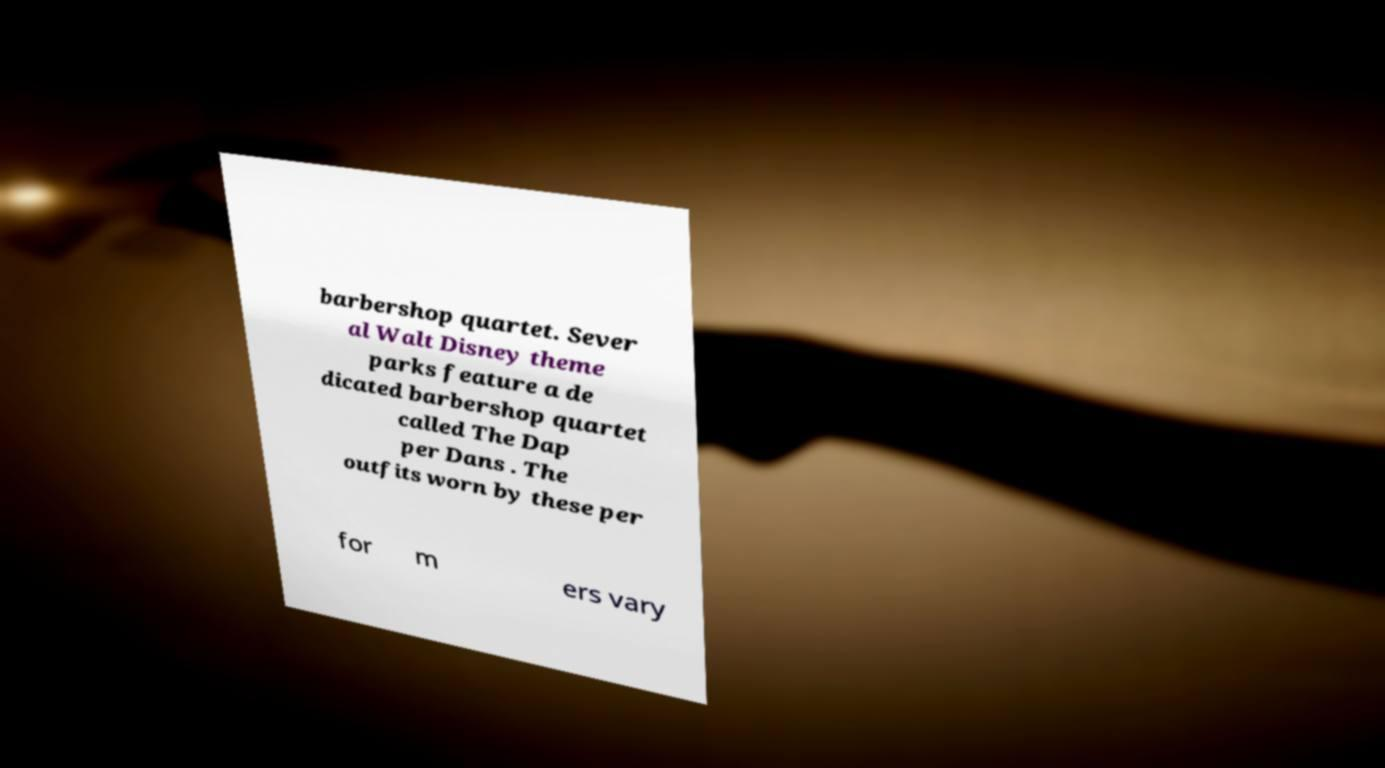Can you read and provide the text displayed in the image?This photo seems to have some interesting text. Can you extract and type it out for me? barbershop quartet. Sever al Walt Disney theme parks feature a de dicated barbershop quartet called The Dap per Dans . The outfits worn by these per for m ers vary 